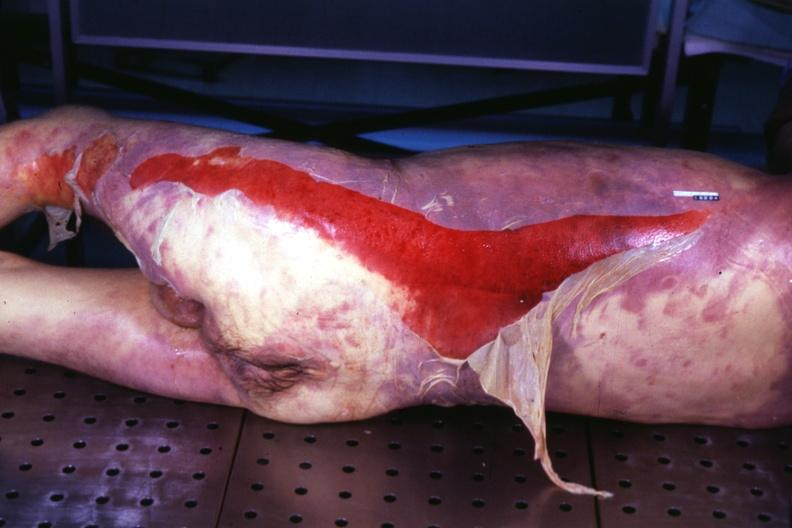what does this image show?
Answer the question using a single word or phrase. Body with extensive ecchymoses and desquamation 